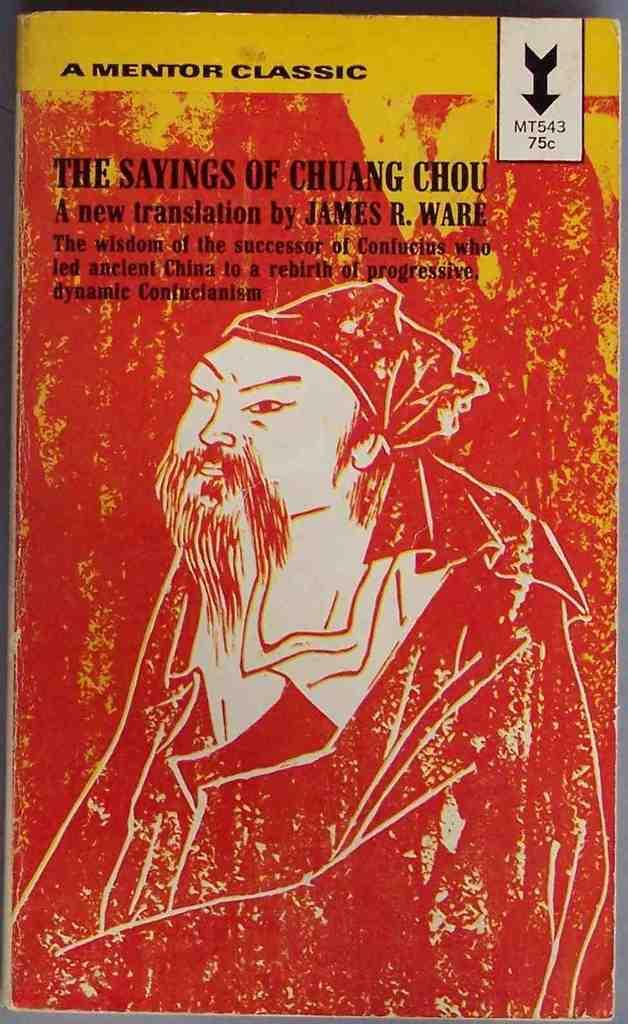What is the name of this book?
Offer a terse response. The sayings of chuang chou. Who is the author of this book?
Your response must be concise. James r ware. 